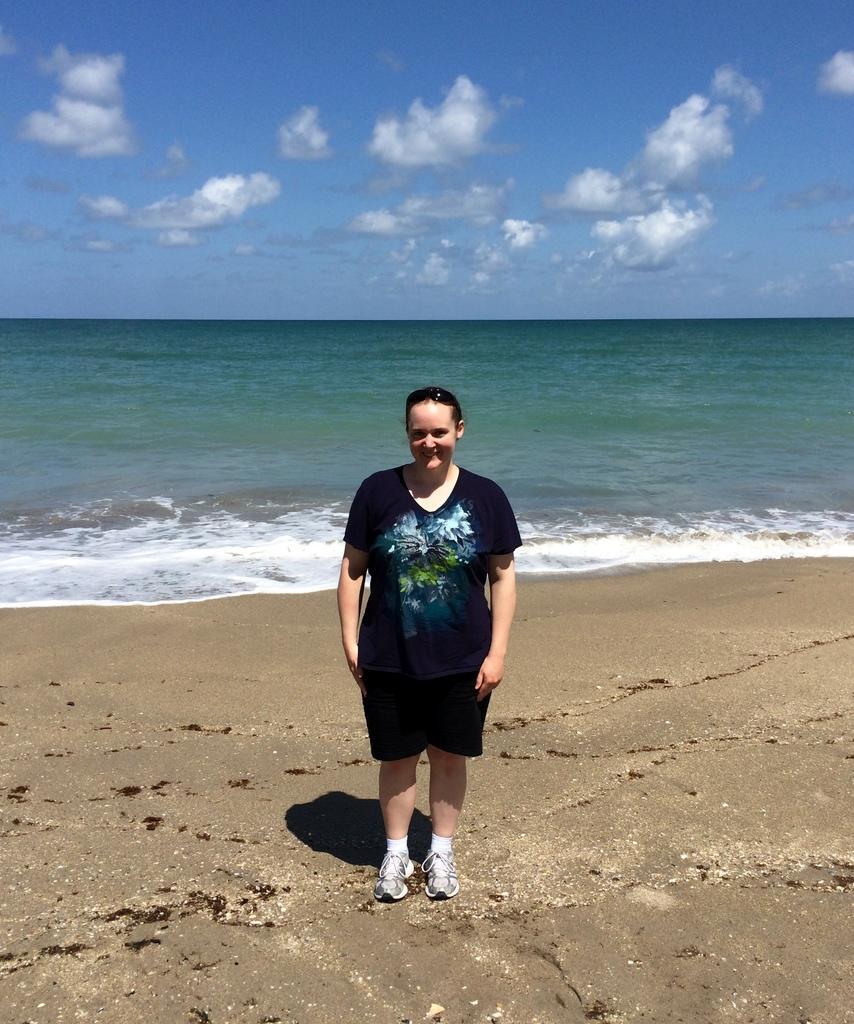In one or two sentences, can you explain what this image depicts? In this image, we can see a person standing and wearing clothes in the beach. There are some clouds in the sky. 